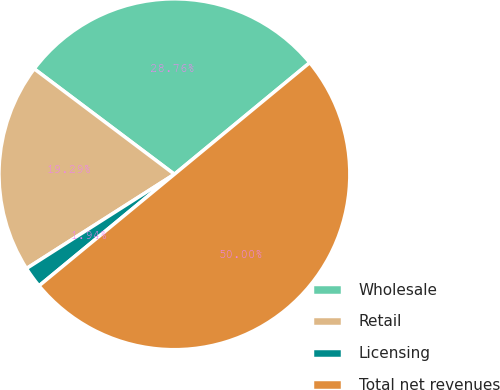<chart> <loc_0><loc_0><loc_500><loc_500><pie_chart><fcel>Wholesale<fcel>Retail<fcel>Licensing<fcel>Total net revenues<nl><fcel>28.76%<fcel>19.29%<fcel>1.94%<fcel>50.0%<nl></chart> 